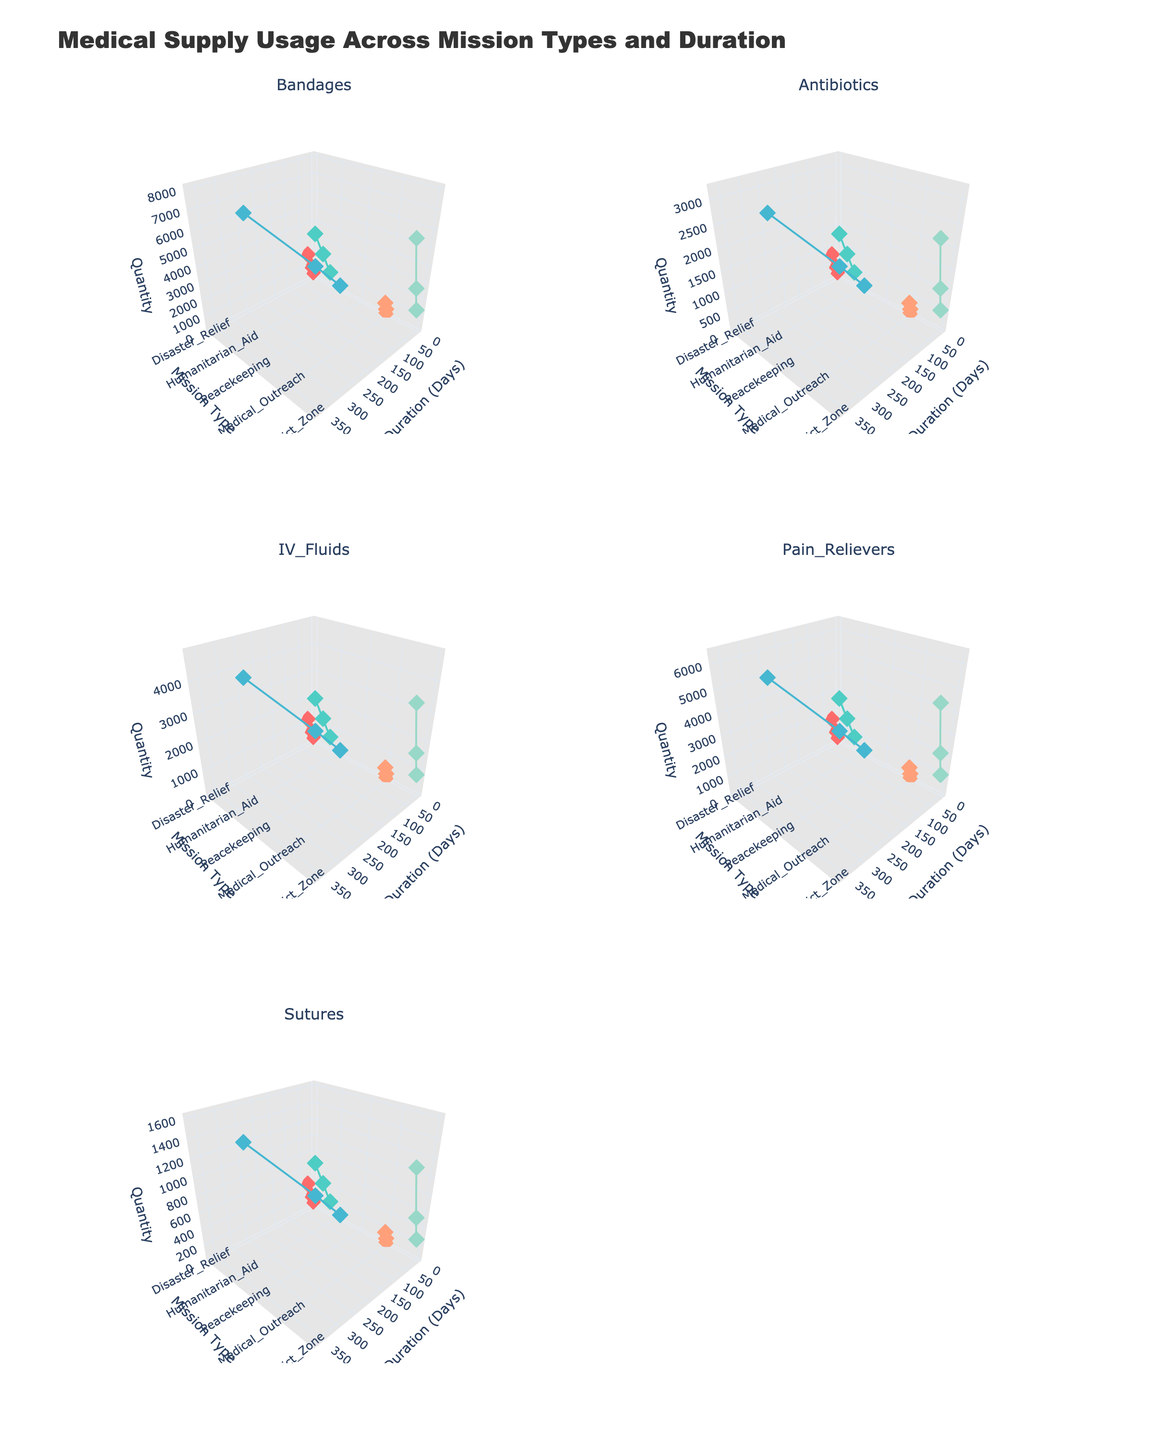What's the title of the figure? The title is located at the top center of the figure and it should clearly describe the visualized data.
Answer: Medical Supply Usage Across Mission Types and Duration How many different mission types are present in the figure? By referring to the legend or observing the categories on the y-axes of the subplots, you can count the unique mission types presented.
Answer: 5 Which mission type has the highest usage of Bandages for a 90-day duration? Look at the 'Bandages' subplot and find the data points associated with each mission type for a 90-day duration. Check which one has the highest value on the z-axis.
Answer: Humanitarian_Aid How does the usage of Sutures compare between Disaster Relief and Conflict Zone missions for a 30-day duration? Compare the z-axis values of Sutures for Disaster Relief and Conflict Zone missions at 30 days duration in the corresponding subplot.
Answer: Disaster Relief has fewer Sutures than Conflict Zone Which mission type exhibits the steepest increase in Pain Relievers usage from 30 to 90 days? Examine the slope and trend lines of the data points between 30 to 90 days within the Pain Relievers subplot for each mission type. The steepest slope indicates the highest increase.
Answer: Humanitarian_Aid For which mission type and duration is the Antibiotics usage closest to 800 units? Look at the 'Antibiotics' subplot and find the data point closest to the 800-unit mark on the z-axis. Note its corresponding mission type and duration.
Answer: Disaster_Relief at 14 days Which supply type has the most consistent usage across all mission types and durations? Check each subplot and observe the variation (range and consistency) in z-axis values across different mission types and durations. The supply type with the least variation is the most consistent.
Answer: Sutures On average, which mission type uses the most IV Fluids? For each mission type, sum up the IV Fluids usage values from all data points and divide by the number of data points to find the average. Compare these averages across mission types.
Answer: Conflict_Zone In the Medical Outreach missions, how does the usage of Bandages change with increasing duration? Examine the trend of the data points in the Bandages subplot for Medical Outreach missions as the duration increases.
Answer: It increases What's the difference in Pain Relievers usage between 60-day Conflict Zone and 30-day Peacekeeping missions? Locate the relevant data points in the Pain Relievers subplot for both conditions and subtract the value for the 30-day Peacekeeping mission from the 60-day Conflict Zone mission.
Answer: 3200 